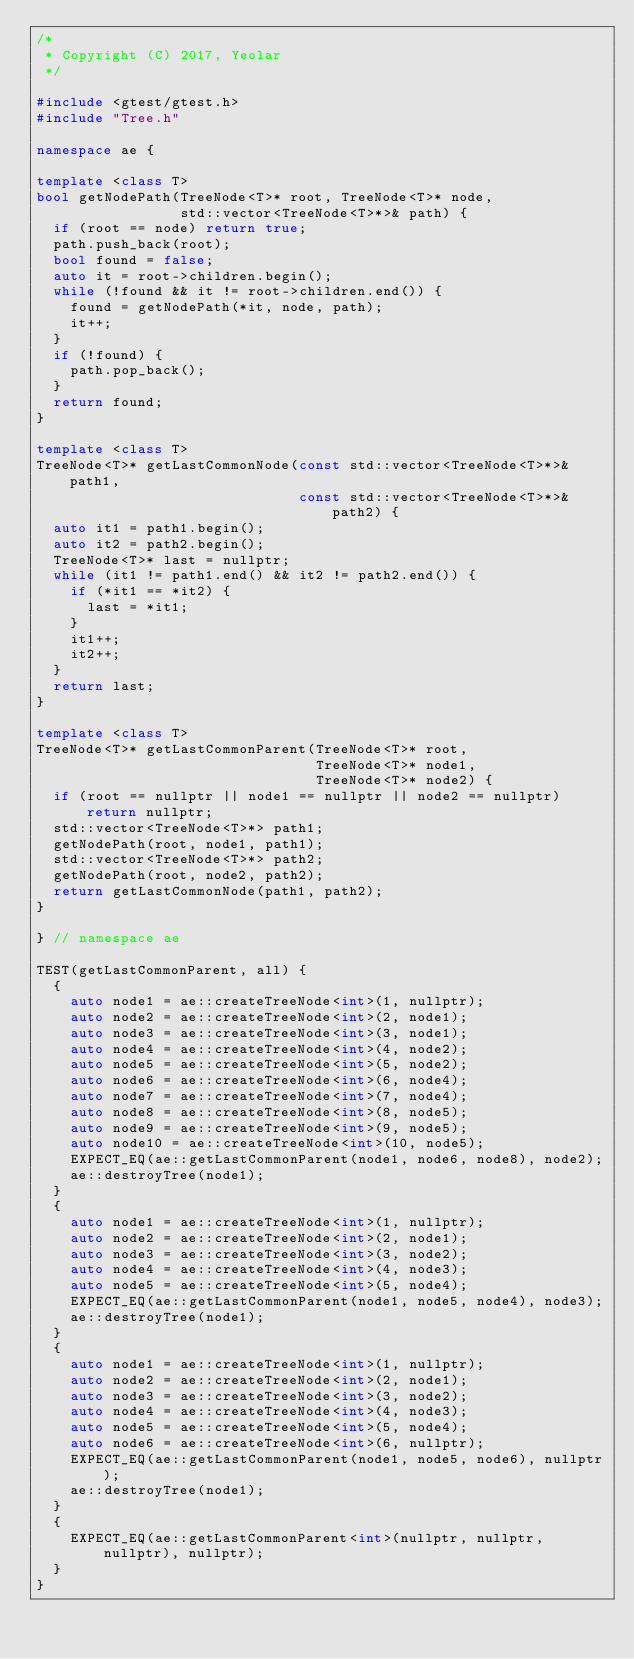<code> <loc_0><loc_0><loc_500><loc_500><_C++_>/*
 * Copyright (C) 2017, Yeolar
 */

#include <gtest/gtest.h>
#include "Tree.h"

namespace ae {

template <class T>
bool getNodePath(TreeNode<T>* root, TreeNode<T>* node,
                 std::vector<TreeNode<T>*>& path) {
  if (root == node) return true;
  path.push_back(root);
  bool found = false;
  auto it = root->children.begin();
  while (!found && it != root->children.end()) {
    found = getNodePath(*it, node, path);
    it++;
  }
  if (!found) {
    path.pop_back();
  }
  return found;
}

template <class T>
TreeNode<T>* getLastCommonNode(const std::vector<TreeNode<T>*>& path1,
                               const std::vector<TreeNode<T>*>& path2) {
  auto it1 = path1.begin();
  auto it2 = path2.begin();
  TreeNode<T>* last = nullptr;
  while (it1 != path1.end() && it2 != path2.end()) {
    if (*it1 == *it2) {
      last = *it1;
    }
    it1++;
    it2++;
  }
  return last;
}

template <class T>
TreeNode<T>* getLastCommonParent(TreeNode<T>* root,
                                 TreeNode<T>* node1,
                                 TreeNode<T>* node2) {
  if (root == nullptr || node1 == nullptr || node2 == nullptr) return nullptr;
  std::vector<TreeNode<T>*> path1;
  getNodePath(root, node1, path1);
  std::vector<TreeNode<T>*> path2;
  getNodePath(root, node2, path2);
  return getLastCommonNode(path1, path2);
}

} // namespace ae

TEST(getLastCommonParent, all) {
  {
    auto node1 = ae::createTreeNode<int>(1, nullptr);
    auto node2 = ae::createTreeNode<int>(2, node1);
    auto node3 = ae::createTreeNode<int>(3, node1);
    auto node4 = ae::createTreeNode<int>(4, node2);
    auto node5 = ae::createTreeNode<int>(5, node2);
    auto node6 = ae::createTreeNode<int>(6, node4);
    auto node7 = ae::createTreeNode<int>(7, node4);
    auto node8 = ae::createTreeNode<int>(8, node5);
    auto node9 = ae::createTreeNode<int>(9, node5);
    auto node10 = ae::createTreeNode<int>(10, node5);
    EXPECT_EQ(ae::getLastCommonParent(node1, node6, node8), node2);
    ae::destroyTree(node1);
  }
  {
    auto node1 = ae::createTreeNode<int>(1, nullptr);
    auto node2 = ae::createTreeNode<int>(2, node1);
    auto node3 = ae::createTreeNode<int>(3, node2);
    auto node4 = ae::createTreeNode<int>(4, node3);
    auto node5 = ae::createTreeNode<int>(5, node4);
    EXPECT_EQ(ae::getLastCommonParent(node1, node5, node4), node3);
    ae::destroyTree(node1);
  }
  {
    auto node1 = ae::createTreeNode<int>(1, nullptr);
    auto node2 = ae::createTreeNode<int>(2, node1);
    auto node3 = ae::createTreeNode<int>(3, node2);
    auto node4 = ae::createTreeNode<int>(4, node3);
    auto node5 = ae::createTreeNode<int>(5, node4);
    auto node6 = ae::createTreeNode<int>(6, nullptr);
    EXPECT_EQ(ae::getLastCommonParent(node1, node5, node6), nullptr);
    ae::destroyTree(node1);
  }
  {
    EXPECT_EQ(ae::getLastCommonParent<int>(nullptr, nullptr, nullptr), nullptr);
  }
}
</code> 